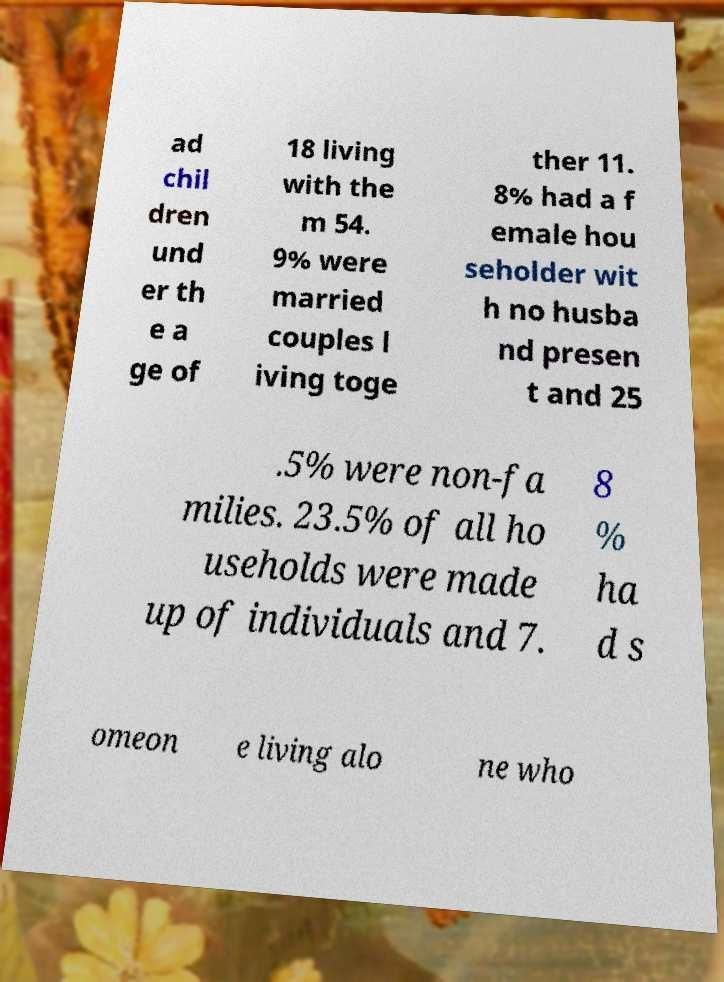There's text embedded in this image that I need extracted. Can you transcribe it verbatim? ad chil dren und er th e a ge of 18 living with the m 54. 9% were married couples l iving toge ther 11. 8% had a f emale hou seholder wit h no husba nd presen t and 25 .5% were non-fa milies. 23.5% of all ho useholds were made up of individuals and 7. 8 % ha d s omeon e living alo ne who 